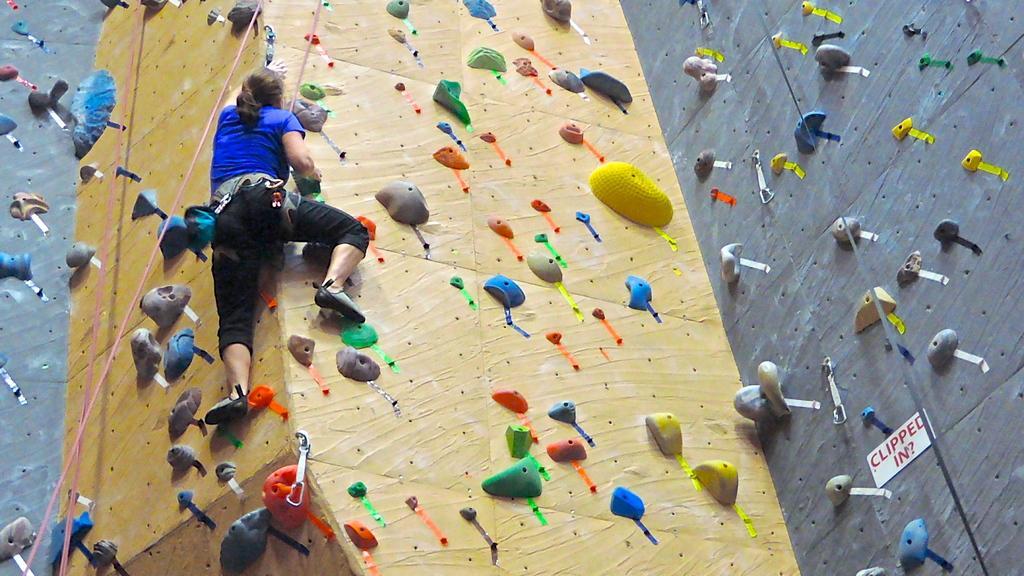Can you describe this image briefly? In this image, I can see a person climbing the wall. These are the ropes. This looks like a board, which is attached to a wall. 